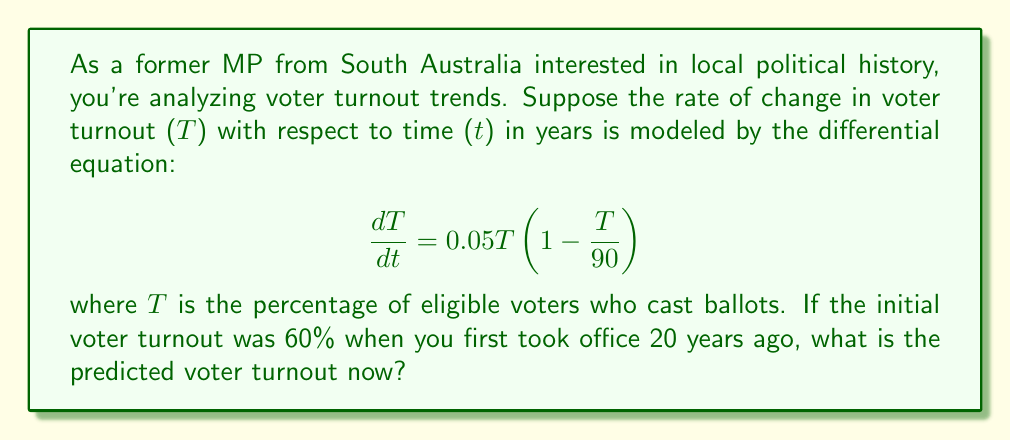Can you answer this question? To solve this problem, we need to use the given first-order differential equation and initial condition. Let's approach this step-by-step:

1) The given differential equation is a logistic growth model:

   $$ \frac{dT}{dt} = 0.05T(1 - \frac{T}{90}) $$

2) The general solution for this type of equation is:

   $$ T(t) = \frac{90}{1 + Ce^{-0.05t}} $$

   where C is a constant we need to determine using the initial condition.

3) We're given that T(0) = 60 (initial turnout 20 years ago). Let's use this to find C:

   $$ 60 = \frac{90}{1 + C} $$

4) Solving for C:

   $$ C = \frac{90}{60} - 1 = 0.5 $$

5) Now we have our specific solution:

   $$ T(t) = \frac{90}{1 + 0.5e^{-0.05t}} $$

6) To find the turnout now, we need to evaluate T(20) since 20 years have passed:

   $$ T(20) = \frac{90}{1 + 0.5e^{-0.05(20)}} $$

7) Calculating:

   $$ T(20) = \frac{90}{1 + 0.5e^{-1}} \approx 74.48 $$

Therefore, the predicted voter turnout now, 20 years later, is approximately 74.48%.
Answer: The predicted voter turnout now, 20 years after you first took office, is approximately 74.48%. 